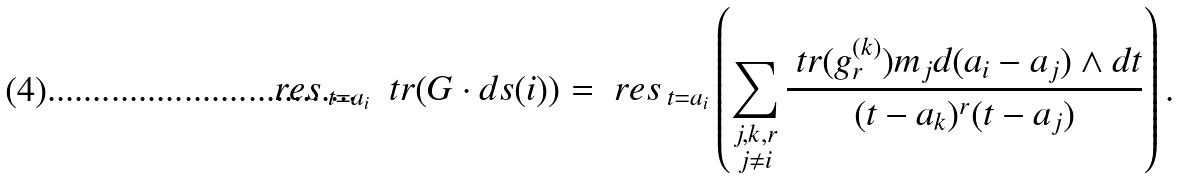Convert formula to latex. <formula><loc_0><loc_0><loc_500><loc_500>\ r e s \, _ { t = a _ { i } } \ \ t r ( G \cdot d s ( i ) ) = \ r e s \, _ { t = a _ { i } } \left ( \sum _ { \substack { j , k , r \\ j \not = i } } \frac { \ t r ( g ^ { ( k ) } _ { r } ) m _ { j } d ( a _ { i } - a _ { j } ) \wedge d t } { ( t - a _ { k } ) ^ { r } ( t - a _ { j } ) } \right ) .</formula> 